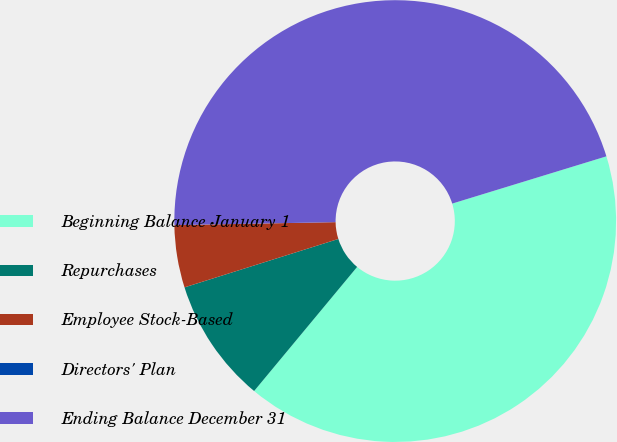<chart> <loc_0><loc_0><loc_500><loc_500><pie_chart><fcel>Beginning Balance January 1<fcel>Repurchases<fcel>Employee Stock-Based<fcel>Directors' Plan<fcel>Ending Balance December 31<nl><fcel>40.76%<fcel>9.12%<fcel>4.56%<fcel>0.0%<fcel>45.56%<nl></chart> 